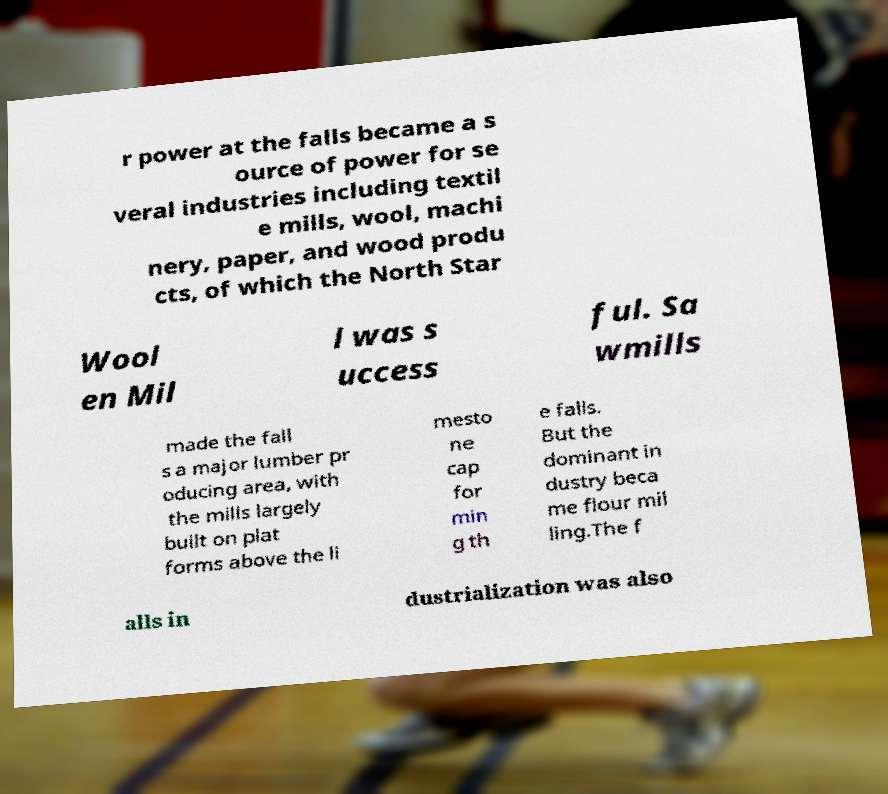Could you assist in decoding the text presented in this image and type it out clearly? r power at the falls became a s ource of power for se veral industries including textil e mills, wool, machi nery, paper, and wood produ cts, of which the North Star Wool en Mil l was s uccess ful. Sa wmills made the fall s a major lumber pr oducing area, with the mills largely built on plat forms above the li mesto ne cap for min g th e falls. But the dominant in dustry beca me flour mil ling.The f alls in dustrialization was also 